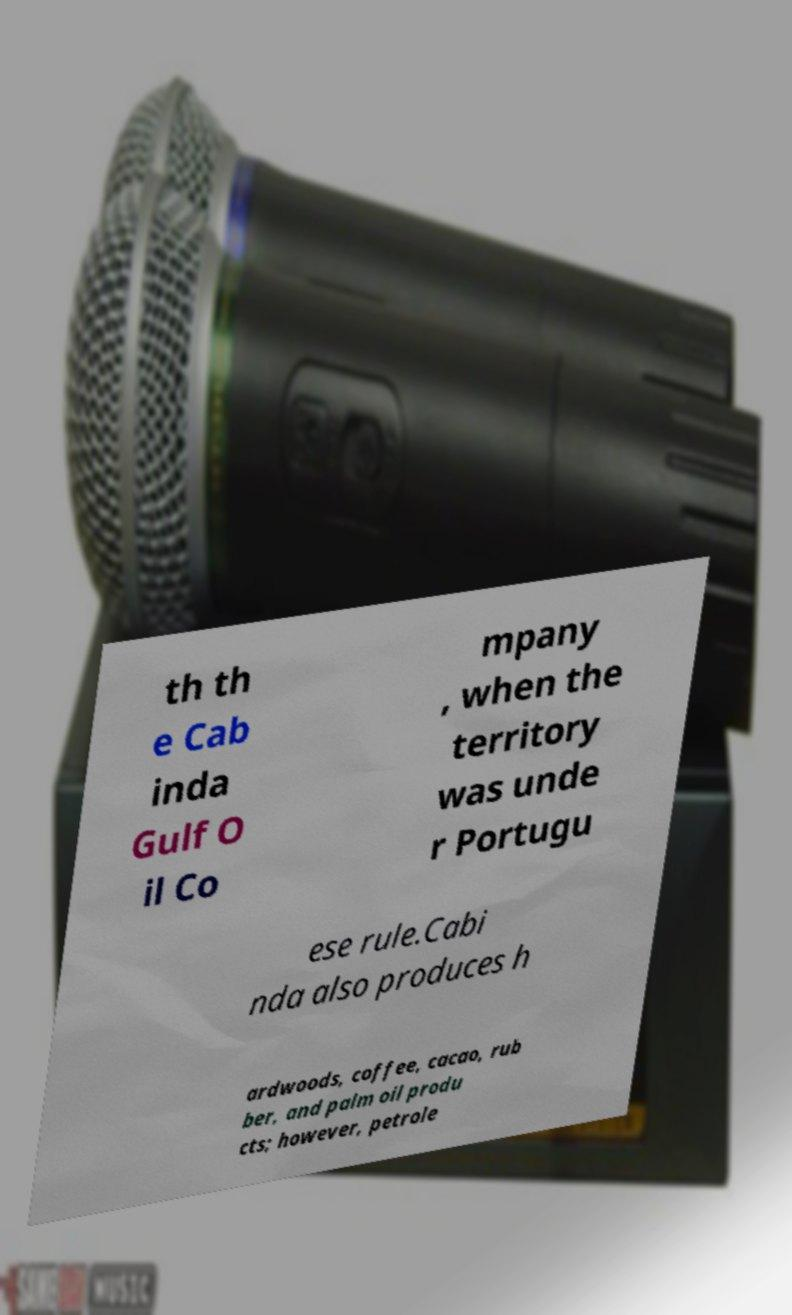Please read and relay the text visible in this image. What does it say? th th e Cab inda Gulf O il Co mpany , when the territory was unde r Portugu ese rule.Cabi nda also produces h ardwoods, coffee, cacao, rub ber, and palm oil produ cts; however, petrole 